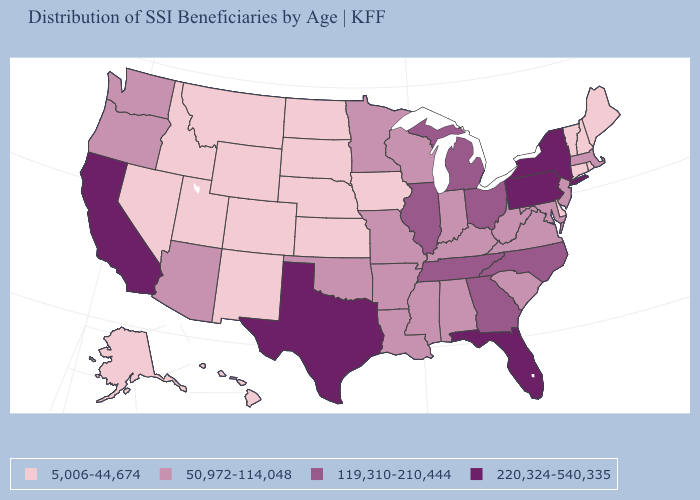What is the lowest value in the USA?
Give a very brief answer. 5,006-44,674. What is the highest value in the USA?
Be succinct. 220,324-540,335. What is the highest value in states that border Wisconsin?
Write a very short answer. 119,310-210,444. What is the value of New Hampshire?
Short answer required. 5,006-44,674. What is the value of Iowa?
Short answer required. 5,006-44,674. Which states have the lowest value in the USA?
Write a very short answer. Alaska, Colorado, Connecticut, Delaware, Hawaii, Idaho, Iowa, Kansas, Maine, Montana, Nebraska, Nevada, New Hampshire, New Mexico, North Dakota, Rhode Island, South Dakota, Utah, Vermont, Wyoming. Among the states that border Georgia , does Alabama have the highest value?
Concise answer only. No. Name the states that have a value in the range 5,006-44,674?
Answer briefly. Alaska, Colorado, Connecticut, Delaware, Hawaii, Idaho, Iowa, Kansas, Maine, Montana, Nebraska, Nevada, New Hampshire, New Mexico, North Dakota, Rhode Island, South Dakota, Utah, Vermont, Wyoming. Among the states that border Minnesota , which have the highest value?
Answer briefly. Wisconsin. What is the value of New Jersey?
Answer briefly. 50,972-114,048. How many symbols are there in the legend?
Short answer required. 4. Name the states that have a value in the range 5,006-44,674?
Be succinct. Alaska, Colorado, Connecticut, Delaware, Hawaii, Idaho, Iowa, Kansas, Maine, Montana, Nebraska, Nevada, New Hampshire, New Mexico, North Dakota, Rhode Island, South Dakota, Utah, Vermont, Wyoming. Does Illinois have the same value as Tennessee?
Concise answer only. Yes. What is the lowest value in the USA?
Concise answer only. 5,006-44,674. What is the lowest value in states that border Arkansas?
Quick response, please. 50,972-114,048. 